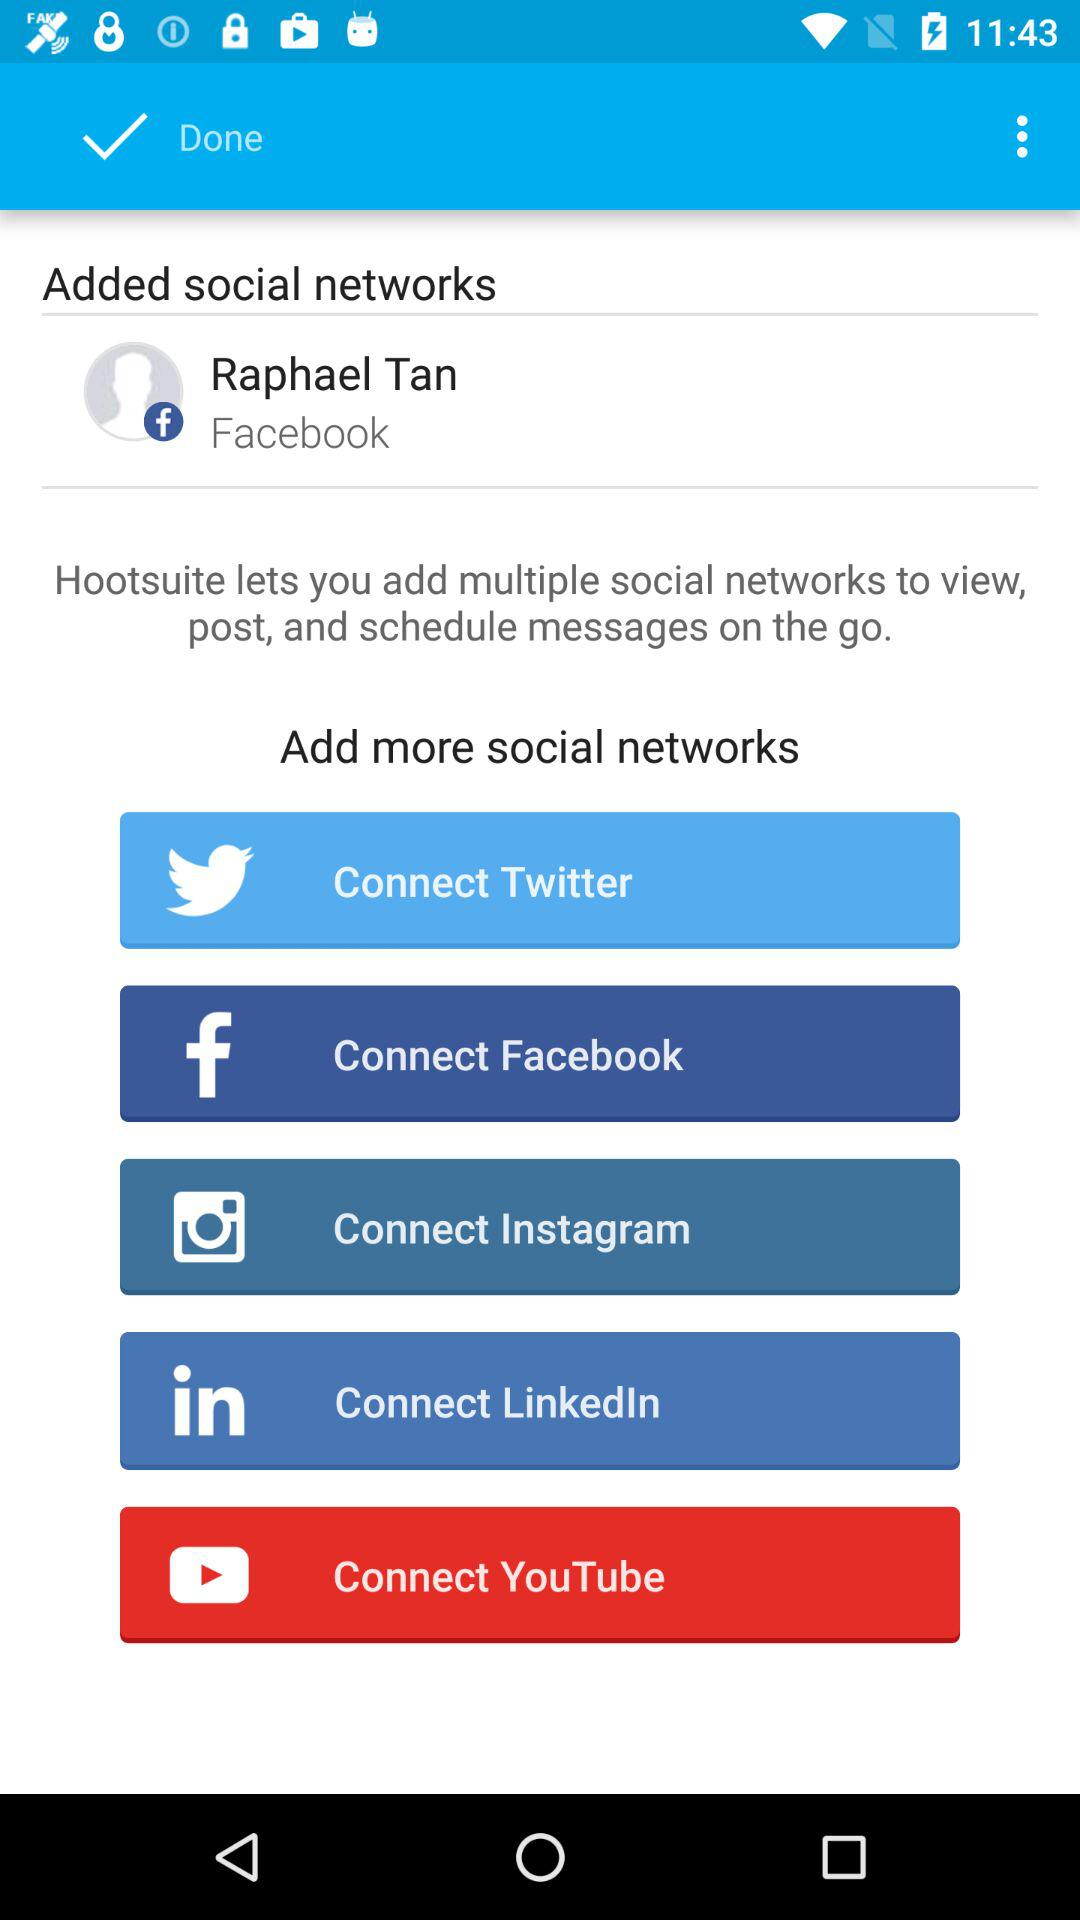Which accounts can I add as my social networks? You can add "Twitter", "Facebook", "Instagram", "LinkedIn" and "YouTube" as your social networks. 